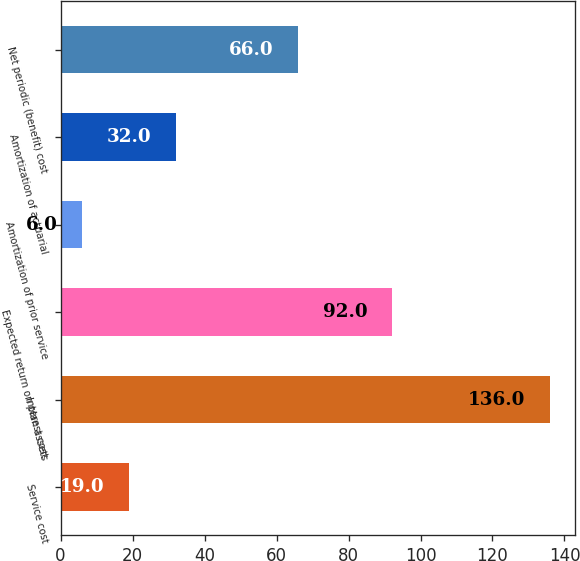<chart> <loc_0><loc_0><loc_500><loc_500><bar_chart><fcel>Service cost<fcel>Interest cost<fcel>Expected return on plan assets<fcel>Amortization of prior service<fcel>Amortization of actuarial<fcel>Net periodic (benefit) cost<nl><fcel>19<fcel>136<fcel>92<fcel>6<fcel>32<fcel>66<nl></chart> 